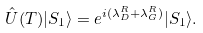<formula> <loc_0><loc_0><loc_500><loc_500>\hat { U } ( T ) | S _ { 1 } \rangle = e ^ { i ( \lambda _ { D } ^ { R } + \lambda _ { G } ^ { R } ) } | S _ { 1 } \rangle .</formula> 